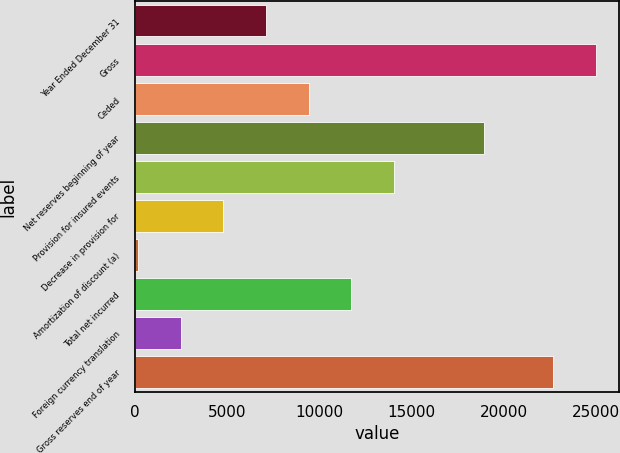<chart> <loc_0><loc_0><loc_500><loc_500><bar_chart><fcel>Year Ended December 31<fcel>Gross<fcel>Ceded<fcel>Net reserves beginning of year<fcel>Provision for insured events<fcel>Decrease in provision for<fcel>Amortization of discount (a)<fcel>Total net incurred<fcel>Foreign currency translation<fcel>Gross reserves end of year<nl><fcel>7097.5<fcel>24973.5<fcel>9408<fcel>18927<fcel>14029<fcel>4787<fcel>166<fcel>11718.5<fcel>2476.5<fcel>22663<nl></chart> 